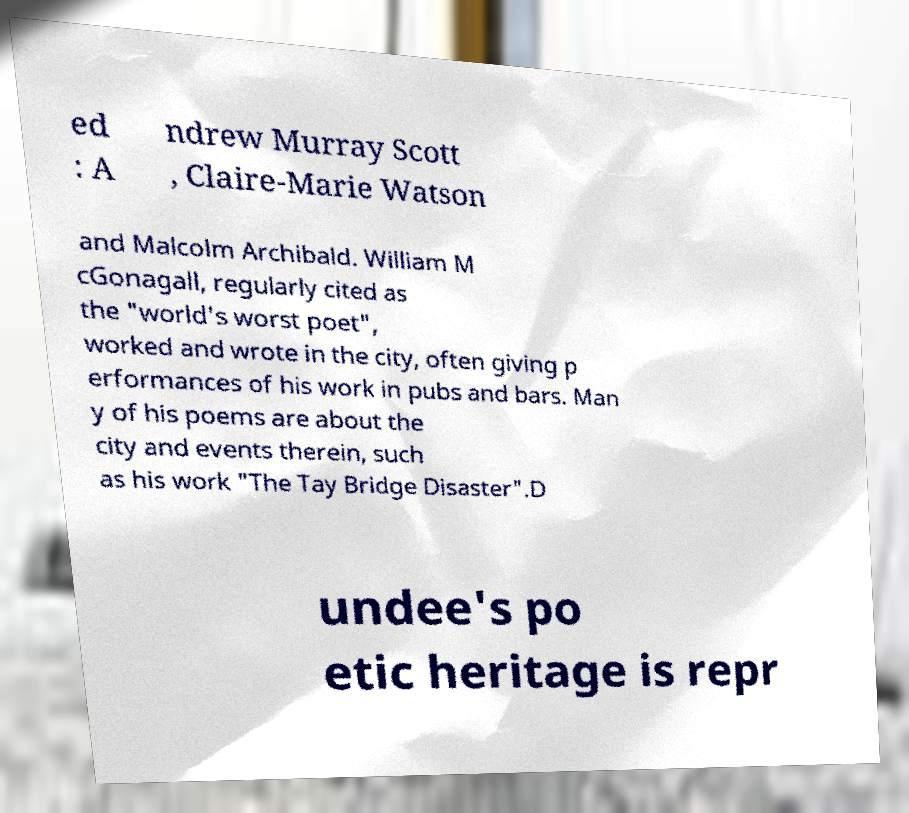What messages or text are displayed in this image? I need them in a readable, typed format. ed : A ndrew Murray Scott , Claire-Marie Watson and Malcolm Archibald. William M cGonagall, regularly cited as the "world's worst poet", worked and wrote in the city, often giving p erformances of his work in pubs and bars. Man y of his poems are about the city and events therein, such as his work "The Tay Bridge Disaster".D undee's po etic heritage is repr 